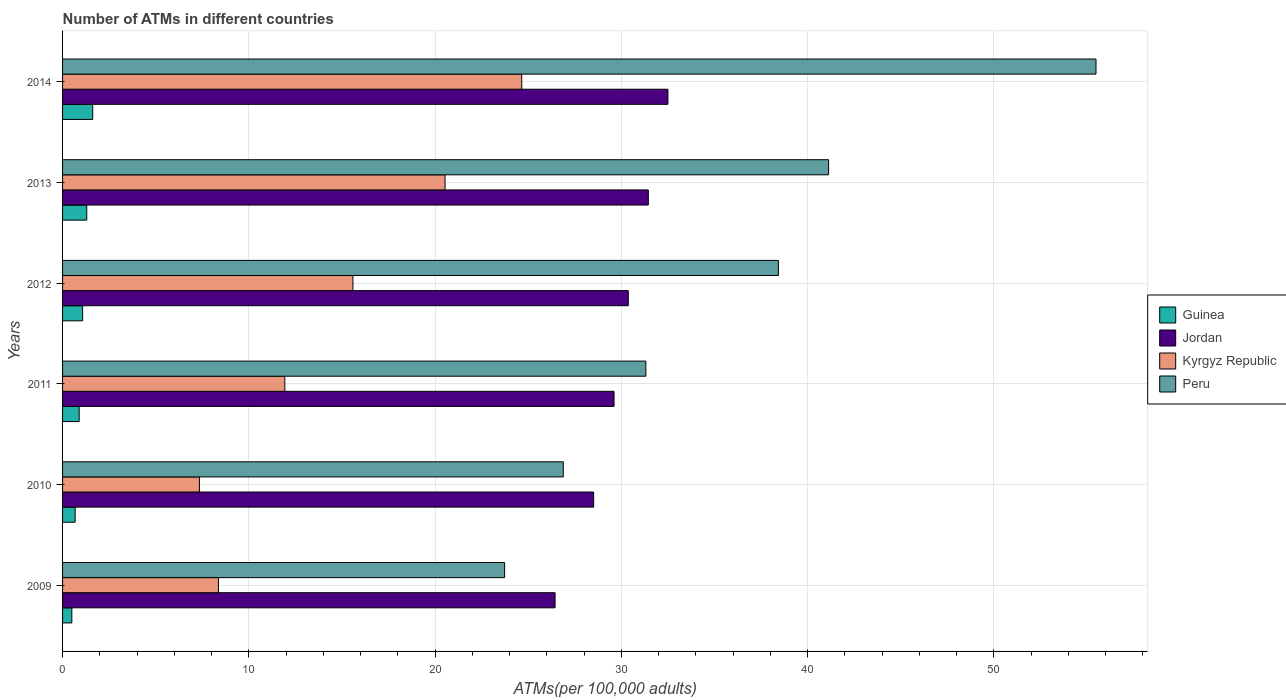How many different coloured bars are there?
Your answer should be very brief. 4. Are the number of bars per tick equal to the number of legend labels?
Ensure brevity in your answer.  Yes. How many bars are there on the 6th tick from the top?
Keep it short and to the point. 4. What is the label of the 2nd group of bars from the top?
Your answer should be compact. 2013. In how many cases, is the number of bars for a given year not equal to the number of legend labels?
Provide a short and direct response. 0. What is the number of ATMs in Kyrgyz Republic in 2009?
Give a very brief answer. 8.37. Across all years, what is the maximum number of ATMs in Kyrgyz Republic?
Ensure brevity in your answer.  24.65. Across all years, what is the minimum number of ATMs in Jordan?
Keep it short and to the point. 26.44. What is the total number of ATMs in Kyrgyz Republic in the graph?
Your answer should be very brief. 88.42. What is the difference between the number of ATMs in Jordan in 2013 and that in 2014?
Offer a terse response. -1.05. What is the difference between the number of ATMs in Guinea in 2009 and the number of ATMs in Kyrgyz Republic in 2012?
Offer a terse response. -15.09. What is the average number of ATMs in Guinea per year?
Offer a terse response. 1.01. In the year 2013, what is the difference between the number of ATMs in Kyrgyz Republic and number of ATMs in Jordan?
Offer a very short reply. -10.91. In how many years, is the number of ATMs in Guinea greater than 12 ?
Offer a very short reply. 0. What is the ratio of the number of ATMs in Kyrgyz Republic in 2010 to that in 2014?
Offer a very short reply. 0.3. What is the difference between the highest and the second highest number of ATMs in Jordan?
Provide a succinct answer. 1.05. What is the difference between the highest and the lowest number of ATMs in Kyrgyz Republic?
Make the answer very short. 17.3. In how many years, is the number of ATMs in Kyrgyz Republic greater than the average number of ATMs in Kyrgyz Republic taken over all years?
Keep it short and to the point. 3. Is the sum of the number of ATMs in Peru in 2010 and 2011 greater than the maximum number of ATMs in Kyrgyz Republic across all years?
Give a very brief answer. Yes. Is it the case that in every year, the sum of the number of ATMs in Kyrgyz Republic and number of ATMs in Peru is greater than the sum of number of ATMs in Guinea and number of ATMs in Jordan?
Your response must be concise. No. What does the 2nd bar from the top in 2014 represents?
Keep it short and to the point. Kyrgyz Republic. What does the 3rd bar from the bottom in 2009 represents?
Keep it short and to the point. Kyrgyz Republic. Is it the case that in every year, the sum of the number of ATMs in Guinea and number of ATMs in Kyrgyz Republic is greater than the number of ATMs in Jordan?
Your response must be concise. No. Are all the bars in the graph horizontal?
Keep it short and to the point. Yes. How are the legend labels stacked?
Provide a succinct answer. Vertical. What is the title of the graph?
Your answer should be very brief. Number of ATMs in different countries. Does "Pakistan" appear as one of the legend labels in the graph?
Offer a very short reply. No. What is the label or title of the X-axis?
Your response must be concise. ATMs(per 100,0 adults). What is the label or title of the Y-axis?
Keep it short and to the point. Years. What is the ATMs(per 100,000 adults) of Guinea in 2009?
Provide a short and direct response. 0.5. What is the ATMs(per 100,000 adults) in Jordan in 2009?
Keep it short and to the point. 26.44. What is the ATMs(per 100,000 adults) in Kyrgyz Republic in 2009?
Offer a terse response. 8.37. What is the ATMs(per 100,000 adults) in Peru in 2009?
Your response must be concise. 23.73. What is the ATMs(per 100,000 adults) in Guinea in 2010?
Keep it short and to the point. 0.68. What is the ATMs(per 100,000 adults) of Jordan in 2010?
Ensure brevity in your answer.  28.51. What is the ATMs(per 100,000 adults) of Kyrgyz Republic in 2010?
Your answer should be very brief. 7.35. What is the ATMs(per 100,000 adults) in Peru in 2010?
Provide a short and direct response. 26.88. What is the ATMs(per 100,000 adults) of Guinea in 2011?
Your answer should be very brief. 0.89. What is the ATMs(per 100,000 adults) in Jordan in 2011?
Provide a short and direct response. 29.61. What is the ATMs(per 100,000 adults) of Kyrgyz Republic in 2011?
Provide a short and direct response. 11.93. What is the ATMs(per 100,000 adults) in Peru in 2011?
Your answer should be very brief. 31.31. What is the ATMs(per 100,000 adults) in Guinea in 2012?
Provide a succinct answer. 1.08. What is the ATMs(per 100,000 adults) of Jordan in 2012?
Keep it short and to the point. 30.37. What is the ATMs(per 100,000 adults) in Kyrgyz Republic in 2012?
Make the answer very short. 15.59. What is the ATMs(per 100,000 adults) of Peru in 2012?
Provide a succinct answer. 38.43. What is the ATMs(per 100,000 adults) of Guinea in 2013?
Keep it short and to the point. 1.3. What is the ATMs(per 100,000 adults) in Jordan in 2013?
Give a very brief answer. 31.45. What is the ATMs(per 100,000 adults) in Kyrgyz Republic in 2013?
Offer a very short reply. 20.53. What is the ATMs(per 100,000 adults) in Peru in 2013?
Your answer should be very brief. 41.12. What is the ATMs(per 100,000 adults) of Guinea in 2014?
Offer a terse response. 1.62. What is the ATMs(per 100,000 adults) in Jordan in 2014?
Your response must be concise. 32.5. What is the ATMs(per 100,000 adults) of Kyrgyz Republic in 2014?
Your response must be concise. 24.65. What is the ATMs(per 100,000 adults) of Peru in 2014?
Your answer should be very brief. 55.48. Across all years, what is the maximum ATMs(per 100,000 adults) of Guinea?
Keep it short and to the point. 1.62. Across all years, what is the maximum ATMs(per 100,000 adults) of Jordan?
Offer a very short reply. 32.5. Across all years, what is the maximum ATMs(per 100,000 adults) of Kyrgyz Republic?
Your answer should be very brief. 24.65. Across all years, what is the maximum ATMs(per 100,000 adults) in Peru?
Provide a short and direct response. 55.48. Across all years, what is the minimum ATMs(per 100,000 adults) in Guinea?
Keep it short and to the point. 0.5. Across all years, what is the minimum ATMs(per 100,000 adults) of Jordan?
Your answer should be compact. 26.44. Across all years, what is the minimum ATMs(per 100,000 adults) of Kyrgyz Republic?
Provide a short and direct response. 7.35. Across all years, what is the minimum ATMs(per 100,000 adults) in Peru?
Make the answer very short. 23.73. What is the total ATMs(per 100,000 adults) of Guinea in the graph?
Provide a succinct answer. 6.06. What is the total ATMs(per 100,000 adults) in Jordan in the graph?
Your answer should be compact. 178.88. What is the total ATMs(per 100,000 adults) of Kyrgyz Republic in the graph?
Make the answer very short. 88.42. What is the total ATMs(per 100,000 adults) of Peru in the graph?
Give a very brief answer. 216.96. What is the difference between the ATMs(per 100,000 adults) of Guinea in 2009 and that in 2010?
Provide a succinct answer. -0.18. What is the difference between the ATMs(per 100,000 adults) of Jordan in 2009 and that in 2010?
Ensure brevity in your answer.  -2.07. What is the difference between the ATMs(per 100,000 adults) of Kyrgyz Republic in 2009 and that in 2010?
Your response must be concise. 1.02. What is the difference between the ATMs(per 100,000 adults) in Peru in 2009 and that in 2010?
Your answer should be very brief. -3.15. What is the difference between the ATMs(per 100,000 adults) of Guinea in 2009 and that in 2011?
Offer a terse response. -0.39. What is the difference between the ATMs(per 100,000 adults) of Jordan in 2009 and that in 2011?
Ensure brevity in your answer.  -3.17. What is the difference between the ATMs(per 100,000 adults) in Kyrgyz Republic in 2009 and that in 2011?
Offer a very short reply. -3.56. What is the difference between the ATMs(per 100,000 adults) of Peru in 2009 and that in 2011?
Give a very brief answer. -7.58. What is the difference between the ATMs(per 100,000 adults) in Guinea in 2009 and that in 2012?
Provide a succinct answer. -0.58. What is the difference between the ATMs(per 100,000 adults) in Jordan in 2009 and that in 2012?
Provide a short and direct response. -3.93. What is the difference between the ATMs(per 100,000 adults) in Kyrgyz Republic in 2009 and that in 2012?
Provide a short and direct response. -7.22. What is the difference between the ATMs(per 100,000 adults) of Peru in 2009 and that in 2012?
Ensure brevity in your answer.  -14.7. What is the difference between the ATMs(per 100,000 adults) in Guinea in 2009 and that in 2013?
Provide a succinct answer. -0.8. What is the difference between the ATMs(per 100,000 adults) in Jordan in 2009 and that in 2013?
Your response must be concise. -5.01. What is the difference between the ATMs(per 100,000 adults) of Kyrgyz Republic in 2009 and that in 2013?
Your answer should be compact. -12.16. What is the difference between the ATMs(per 100,000 adults) of Peru in 2009 and that in 2013?
Offer a terse response. -17.39. What is the difference between the ATMs(per 100,000 adults) of Guinea in 2009 and that in 2014?
Provide a succinct answer. -1.12. What is the difference between the ATMs(per 100,000 adults) of Jordan in 2009 and that in 2014?
Provide a short and direct response. -6.06. What is the difference between the ATMs(per 100,000 adults) of Kyrgyz Republic in 2009 and that in 2014?
Keep it short and to the point. -16.28. What is the difference between the ATMs(per 100,000 adults) in Peru in 2009 and that in 2014?
Keep it short and to the point. -31.75. What is the difference between the ATMs(per 100,000 adults) in Guinea in 2010 and that in 2011?
Offer a terse response. -0.21. What is the difference between the ATMs(per 100,000 adults) of Jordan in 2010 and that in 2011?
Provide a succinct answer. -1.09. What is the difference between the ATMs(per 100,000 adults) of Kyrgyz Republic in 2010 and that in 2011?
Provide a succinct answer. -4.58. What is the difference between the ATMs(per 100,000 adults) of Peru in 2010 and that in 2011?
Ensure brevity in your answer.  -4.43. What is the difference between the ATMs(per 100,000 adults) of Guinea in 2010 and that in 2012?
Keep it short and to the point. -0.4. What is the difference between the ATMs(per 100,000 adults) in Jordan in 2010 and that in 2012?
Offer a very short reply. -1.86. What is the difference between the ATMs(per 100,000 adults) in Kyrgyz Republic in 2010 and that in 2012?
Keep it short and to the point. -8.24. What is the difference between the ATMs(per 100,000 adults) of Peru in 2010 and that in 2012?
Ensure brevity in your answer.  -11.55. What is the difference between the ATMs(per 100,000 adults) of Guinea in 2010 and that in 2013?
Your answer should be compact. -0.62. What is the difference between the ATMs(per 100,000 adults) in Jordan in 2010 and that in 2013?
Your answer should be very brief. -2.94. What is the difference between the ATMs(per 100,000 adults) in Kyrgyz Republic in 2010 and that in 2013?
Your answer should be very brief. -13.19. What is the difference between the ATMs(per 100,000 adults) of Peru in 2010 and that in 2013?
Provide a short and direct response. -14.24. What is the difference between the ATMs(per 100,000 adults) of Guinea in 2010 and that in 2014?
Offer a very short reply. -0.94. What is the difference between the ATMs(per 100,000 adults) in Jordan in 2010 and that in 2014?
Your answer should be very brief. -3.99. What is the difference between the ATMs(per 100,000 adults) of Kyrgyz Republic in 2010 and that in 2014?
Offer a very short reply. -17.3. What is the difference between the ATMs(per 100,000 adults) of Peru in 2010 and that in 2014?
Your answer should be very brief. -28.6. What is the difference between the ATMs(per 100,000 adults) of Guinea in 2011 and that in 2012?
Provide a succinct answer. -0.19. What is the difference between the ATMs(per 100,000 adults) of Jordan in 2011 and that in 2012?
Provide a succinct answer. -0.76. What is the difference between the ATMs(per 100,000 adults) in Kyrgyz Republic in 2011 and that in 2012?
Provide a succinct answer. -3.66. What is the difference between the ATMs(per 100,000 adults) of Peru in 2011 and that in 2012?
Your answer should be compact. -7.12. What is the difference between the ATMs(per 100,000 adults) of Guinea in 2011 and that in 2013?
Provide a short and direct response. -0.41. What is the difference between the ATMs(per 100,000 adults) of Jordan in 2011 and that in 2013?
Offer a very short reply. -1.84. What is the difference between the ATMs(per 100,000 adults) of Kyrgyz Republic in 2011 and that in 2013?
Make the answer very short. -8.6. What is the difference between the ATMs(per 100,000 adults) of Peru in 2011 and that in 2013?
Provide a short and direct response. -9.81. What is the difference between the ATMs(per 100,000 adults) of Guinea in 2011 and that in 2014?
Keep it short and to the point. -0.73. What is the difference between the ATMs(per 100,000 adults) of Jordan in 2011 and that in 2014?
Keep it short and to the point. -2.89. What is the difference between the ATMs(per 100,000 adults) of Kyrgyz Republic in 2011 and that in 2014?
Keep it short and to the point. -12.72. What is the difference between the ATMs(per 100,000 adults) in Peru in 2011 and that in 2014?
Give a very brief answer. -24.17. What is the difference between the ATMs(per 100,000 adults) in Guinea in 2012 and that in 2013?
Make the answer very short. -0.22. What is the difference between the ATMs(per 100,000 adults) of Jordan in 2012 and that in 2013?
Offer a terse response. -1.08. What is the difference between the ATMs(per 100,000 adults) in Kyrgyz Republic in 2012 and that in 2013?
Your response must be concise. -4.95. What is the difference between the ATMs(per 100,000 adults) in Peru in 2012 and that in 2013?
Keep it short and to the point. -2.69. What is the difference between the ATMs(per 100,000 adults) of Guinea in 2012 and that in 2014?
Give a very brief answer. -0.54. What is the difference between the ATMs(per 100,000 adults) in Jordan in 2012 and that in 2014?
Provide a succinct answer. -2.13. What is the difference between the ATMs(per 100,000 adults) in Kyrgyz Republic in 2012 and that in 2014?
Your answer should be compact. -9.06. What is the difference between the ATMs(per 100,000 adults) in Peru in 2012 and that in 2014?
Your answer should be very brief. -17.05. What is the difference between the ATMs(per 100,000 adults) in Guinea in 2013 and that in 2014?
Make the answer very short. -0.32. What is the difference between the ATMs(per 100,000 adults) of Jordan in 2013 and that in 2014?
Provide a succinct answer. -1.05. What is the difference between the ATMs(per 100,000 adults) in Kyrgyz Republic in 2013 and that in 2014?
Ensure brevity in your answer.  -4.12. What is the difference between the ATMs(per 100,000 adults) of Peru in 2013 and that in 2014?
Give a very brief answer. -14.36. What is the difference between the ATMs(per 100,000 adults) in Guinea in 2009 and the ATMs(per 100,000 adults) in Jordan in 2010?
Provide a short and direct response. -28.01. What is the difference between the ATMs(per 100,000 adults) in Guinea in 2009 and the ATMs(per 100,000 adults) in Kyrgyz Republic in 2010?
Make the answer very short. -6.85. What is the difference between the ATMs(per 100,000 adults) in Guinea in 2009 and the ATMs(per 100,000 adults) in Peru in 2010?
Your answer should be compact. -26.39. What is the difference between the ATMs(per 100,000 adults) in Jordan in 2009 and the ATMs(per 100,000 adults) in Kyrgyz Republic in 2010?
Your response must be concise. 19.09. What is the difference between the ATMs(per 100,000 adults) of Jordan in 2009 and the ATMs(per 100,000 adults) of Peru in 2010?
Your answer should be compact. -0.44. What is the difference between the ATMs(per 100,000 adults) of Kyrgyz Republic in 2009 and the ATMs(per 100,000 adults) of Peru in 2010?
Your answer should be compact. -18.51. What is the difference between the ATMs(per 100,000 adults) of Guinea in 2009 and the ATMs(per 100,000 adults) of Jordan in 2011?
Offer a terse response. -29.11. What is the difference between the ATMs(per 100,000 adults) in Guinea in 2009 and the ATMs(per 100,000 adults) in Kyrgyz Republic in 2011?
Provide a short and direct response. -11.43. What is the difference between the ATMs(per 100,000 adults) in Guinea in 2009 and the ATMs(per 100,000 adults) in Peru in 2011?
Ensure brevity in your answer.  -30.82. What is the difference between the ATMs(per 100,000 adults) of Jordan in 2009 and the ATMs(per 100,000 adults) of Kyrgyz Republic in 2011?
Keep it short and to the point. 14.51. What is the difference between the ATMs(per 100,000 adults) in Jordan in 2009 and the ATMs(per 100,000 adults) in Peru in 2011?
Offer a very short reply. -4.87. What is the difference between the ATMs(per 100,000 adults) of Kyrgyz Republic in 2009 and the ATMs(per 100,000 adults) of Peru in 2011?
Ensure brevity in your answer.  -22.95. What is the difference between the ATMs(per 100,000 adults) of Guinea in 2009 and the ATMs(per 100,000 adults) of Jordan in 2012?
Give a very brief answer. -29.87. What is the difference between the ATMs(per 100,000 adults) in Guinea in 2009 and the ATMs(per 100,000 adults) in Kyrgyz Republic in 2012?
Make the answer very short. -15.09. What is the difference between the ATMs(per 100,000 adults) of Guinea in 2009 and the ATMs(per 100,000 adults) of Peru in 2012?
Offer a very short reply. -37.93. What is the difference between the ATMs(per 100,000 adults) in Jordan in 2009 and the ATMs(per 100,000 adults) in Kyrgyz Republic in 2012?
Your answer should be compact. 10.85. What is the difference between the ATMs(per 100,000 adults) of Jordan in 2009 and the ATMs(per 100,000 adults) of Peru in 2012?
Give a very brief answer. -11.99. What is the difference between the ATMs(per 100,000 adults) in Kyrgyz Republic in 2009 and the ATMs(per 100,000 adults) in Peru in 2012?
Offer a terse response. -30.06. What is the difference between the ATMs(per 100,000 adults) of Guinea in 2009 and the ATMs(per 100,000 adults) of Jordan in 2013?
Offer a very short reply. -30.95. What is the difference between the ATMs(per 100,000 adults) of Guinea in 2009 and the ATMs(per 100,000 adults) of Kyrgyz Republic in 2013?
Provide a short and direct response. -20.04. What is the difference between the ATMs(per 100,000 adults) in Guinea in 2009 and the ATMs(per 100,000 adults) in Peru in 2013?
Keep it short and to the point. -40.63. What is the difference between the ATMs(per 100,000 adults) of Jordan in 2009 and the ATMs(per 100,000 adults) of Kyrgyz Republic in 2013?
Your answer should be compact. 5.91. What is the difference between the ATMs(per 100,000 adults) in Jordan in 2009 and the ATMs(per 100,000 adults) in Peru in 2013?
Provide a short and direct response. -14.68. What is the difference between the ATMs(per 100,000 adults) of Kyrgyz Republic in 2009 and the ATMs(per 100,000 adults) of Peru in 2013?
Give a very brief answer. -32.76. What is the difference between the ATMs(per 100,000 adults) of Guinea in 2009 and the ATMs(per 100,000 adults) of Jordan in 2014?
Offer a very short reply. -32. What is the difference between the ATMs(per 100,000 adults) in Guinea in 2009 and the ATMs(per 100,000 adults) in Kyrgyz Republic in 2014?
Provide a succinct answer. -24.15. What is the difference between the ATMs(per 100,000 adults) in Guinea in 2009 and the ATMs(per 100,000 adults) in Peru in 2014?
Give a very brief answer. -54.98. What is the difference between the ATMs(per 100,000 adults) of Jordan in 2009 and the ATMs(per 100,000 adults) of Kyrgyz Republic in 2014?
Offer a very short reply. 1.79. What is the difference between the ATMs(per 100,000 adults) in Jordan in 2009 and the ATMs(per 100,000 adults) in Peru in 2014?
Make the answer very short. -29.04. What is the difference between the ATMs(per 100,000 adults) of Kyrgyz Republic in 2009 and the ATMs(per 100,000 adults) of Peru in 2014?
Make the answer very short. -47.11. What is the difference between the ATMs(per 100,000 adults) of Guinea in 2010 and the ATMs(per 100,000 adults) of Jordan in 2011?
Your answer should be compact. -28.93. What is the difference between the ATMs(per 100,000 adults) in Guinea in 2010 and the ATMs(per 100,000 adults) in Kyrgyz Republic in 2011?
Provide a succinct answer. -11.26. What is the difference between the ATMs(per 100,000 adults) in Guinea in 2010 and the ATMs(per 100,000 adults) in Peru in 2011?
Provide a short and direct response. -30.64. What is the difference between the ATMs(per 100,000 adults) of Jordan in 2010 and the ATMs(per 100,000 adults) of Kyrgyz Republic in 2011?
Give a very brief answer. 16.58. What is the difference between the ATMs(per 100,000 adults) in Jordan in 2010 and the ATMs(per 100,000 adults) in Peru in 2011?
Provide a succinct answer. -2.8. What is the difference between the ATMs(per 100,000 adults) of Kyrgyz Republic in 2010 and the ATMs(per 100,000 adults) of Peru in 2011?
Provide a short and direct response. -23.97. What is the difference between the ATMs(per 100,000 adults) in Guinea in 2010 and the ATMs(per 100,000 adults) in Jordan in 2012?
Provide a succinct answer. -29.7. What is the difference between the ATMs(per 100,000 adults) of Guinea in 2010 and the ATMs(per 100,000 adults) of Kyrgyz Republic in 2012?
Make the answer very short. -14.91. What is the difference between the ATMs(per 100,000 adults) in Guinea in 2010 and the ATMs(per 100,000 adults) in Peru in 2012?
Make the answer very short. -37.76. What is the difference between the ATMs(per 100,000 adults) in Jordan in 2010 and the ATMs(per 100,000 adults) in Kyrgyz Republic in 2012?
Your answer should be compact. 12.92. What is the difference between the ATMs(per 100,000 adults) in Jordan in 2010 and the ATMs(per 100,000 adults) in Peru in 2012?
Make the answer very short. -9.92. What is the difference between the ATMs(per 100,000 adults) in Kyrgyz Republic in 2010 and the ATMs(per 100,000 adults) in Peru in 2012?
Make the answer very short. -31.08. What is the difference between the ATMs(per 100,000 adults) of Guinea in 2010 and the ATMs(per 100,000 adults) of Jordan in 2013?
Provide a short and direct response. -30.77. What is the difference between the ATMs(per 100,000 adults) in Guinea in 2010 and the ATMs(per 100,000 adults) in Kyrgyz Republic in 2013?
Your answer should be compact. -19.86. What is the difference between the ATMs(per 100,000 adults) in Guinea in 2010 and the ATMs(per 100,000 adults) in Peru in 2013?
Make the answer very short. -40.45. What is the difference between the ATMs(per 100,000 adults) of Jordan in 2010 and the ATMs(per 100,000 adults) of Kyrgyz Republic in 2013?
Provide a short and direct response. 7.98. What is the difference between the ATMs(per 100,000 adults) of Jordan in 2010 and the ATMs(per 100,000 adults) of Peru in 2013?
Give a very brief answer. -12.61. What is the difference between the ATMs(per 100,000 adults) of Kyrgyz Republic in 2010 and the ATMs(per 100,000 adults) of Peru in 2013?
Offer a very short reply. -33.78. What is the difference between the ATMs(per 100,000 adults) of Guinea in 2010 and the ATMs(per 100,000 adults) of Jordan in 2014?
Provide a short and direct response. -31.82. What is the difference between the ATMs(per 100,000 adults) of Guinea in 2010 and the ATMs(per 100,000 adults) of Kyrgyz Republic in 2014?
Keep it short and to the point. -23.98. What is the difference between the ATMs(per 100,000 adults) of Guinea in 2010 and the ATMs(per 100,000 adults) of Peru in 2014?
Provide a succinct answer. -54.81. What is the difference between the ATMs(per 100,000 adults) of Jordan in 2010 and the ATMs(per 100,000 adults) of Kyrgyz Republic in 2014?
Offer a terse response. 3.86. What is the difference between the ATMs(per 100,000 adults) in Jordan in 2010 and the ATMs(per 100,000 adults) in Peru in 2014?
Your answer should be compact. -26.97. What is the difference between the ATMs(per 100,000 adults) in Kyrgyz Republic in 2010 and the ATMs(per 100,000 adults) in Peru in 2014?
Your answer should be compact. -48.13. What is the difference between the ATMs(per 100,000 adults) of Guinea in 2011 and the ATMs(per 100,000 adults) of Jordan in 2012?
Keep it short and to the point. -29.48. What is the difference between the ATMs(per 100,000 adults) in Guinea in 2011 and the ATMs(per 100,000 adults) in Kyrgyz Republic in 2012?
Make the answer very short. -14.7. What is the difference between the ATMs(per 100,000 adults) of Guinea in 2011 and the ATMs(per 100,000 adults) of Peru in 2012?
Provide a succinct answer. -37.54. What is the difference between the ATMs(per 100,000 adults) of Jordan in 2011 and the ATMs(per 100,000 adults) of Kyrgyz Republic in 2012?
Give a very brief answer. 14.02. What is the difference between the ATMs(per 100,000 adults) in Jordan in 2011 and the ATMs(per 100,000 adults) in Peru in 2012?
Provide a short and direct response. -8.82. What is the difference between the ATMs(per 100,000 adults) in Kyrgyz Republic in 2011 and the ATMs(per 100,000 adults) in Peru in 2012?
Keep it short and to the point. -26.5. What is the difference between the ATMs(per 100,000 adults) of Guinea in 2011 and the ATMs(per 100,000 adults) of Jordan in 2013?
Ensure brevity in your answer.  -30.56. What is the difference between the ATMs(per 100,000 adults) of Guinea in 2011 and the ATMs(per 100,000 adults) of Kyrgyz Republic in 2013?
Your answer should be very brief. -19.64. What is the difference between the ATMs(per 100,000 adults) of Guinea in 2011 and the ATMs(per 100,000 adults) of Peru in 2013?
Your answer should be very brief. -40.23. What is the difference between the ATMs(per 100,000 adults) in Jordan in 2011 and the ATMs(per 100,000 adults) in Kyrgyz Republic in 2013?
Offer a very short reply. 9.07. What is the difference between the ATMs(per 100,000 adults) of Jordan in 2011 and the ATMs(per 100,000 adults) of Peru in 2013?
Offer a terse response. -11.52. What is the difference between the ATMs(per 100,000 adults) of Kyrgyz Republic in 2011 and the ATMs(per 100,000 adults) of Peru in 2013?
Your response must be concise. -29.19. What is the difference between the ATMs(per 100,000 adults) of Guinea in 2011 and the ATMs(per 100,000 adults) of Jordan in 2014?
Make the answer very short. -31.61. What is the difference between the ATMs(per 100,000 adults) of Guinea in 2011 and the ATMs(per 100,000 adults) of Kyrgyz Republic in 2014?
Your answer should be compact. -23.76. What is the difference between the ATMs(per 100,000 adults) of Guinea in 2011 and the ATMs(per 100,000 adults) of Peru in 2014?
Give a very brief answer. -54.59. What is the difference between the ATMs(per 100,000 adults) in Jordan in 2011 and the ATMs(per 100,000 adults) in Kyrgyz Republic in 2014?
Offer a very short reply. 4.96. What is the difference between the ATMs(per 100,000 adults) of Jordan in 2011 and the ATMs(per 100,000 adults) of Peru in 2014?
Your response must be concise. -25.87. What is the difference between the ATMs(per 100,000 adults) in Kyrgyz Republic in 2011 and the ATMs(per 100,000 adults) in Peru in 2014?
Provide a short and direct response. -43.55. What is the difference between the ATMs(per 100,000 adults) of Guinea in 2012 and the ATMs(per 100,000 adults) of Jordan in 2013?
Make the answer very short. -30.37. What is the difference between the ATMs(per 100,000 adults) of Guinea in 2012 and the ATMs(per 100,000 adults) of Kyrgyz Republic in 2013?
Keep it short and to the point. -19.46. What is the difference between the ATMs(per 100,000 adults) of Guinea in 2012 and the ATMs(per 100,000 adults) of Peru in 2013?
Your answer should be compact. -40.05. What is the difference between the ATMs(per 100,000 adults) in Jordan in 2012 and the ATMs(per 100,000 adults) in Kyrgyz Republic in 2013?
Keep it short and to the point. 9.84. What is the difference between the ATMs(per 100,000 adults) of Jordan in 2012 and the ATMs(per 100,000 adults) of Peru in 2013?
Keep it short and to the point. -10.75. What is the difference between the ATMs(per 100,000 adults) in Kyrgyz Republic in 2012 and the ATMs(per 100,000 adults) in Peru in 2013?
Keep it short and to the point. -25.54. What is the difference between the ATMs(per 100,000 adults) of Guinea in 2012 and the ATMs(per 100,000 adults) of Jordan in 2014?
Give a very brief answer. -31.42. What is the difference between the ATMs(per 100,000 adults) of Guinea in 2012 and the ATMs(per 100,000 adults) of Kyrgyz Republic in 2014?
Provide a succinct answer. -23.57. What is the difference between the ATMs(per 100,000 adults) in Guinea in 2012 and the ATMs(per 100,000 adults) in Peru in 2014?
Provide a succinct answer. -54.4. What is the difference between the ATMs(per 100,000 adults) of Jordan in 2012 and the ATMs(per 100,000 adults) of Kyrgyz Republic in 2014?
Provide a succinct answer. 5.72. What is the difference between the ATMs(per 100,000 adults) in Jordan in 2012 and the ATMs(per 100,000 adults) in Peru in 2014?
Your answer should be compact. -25.11. What is the difference between the ATMs(per 100,000 adults) in Kyrgyz Republic in 2012 and the ATMs(per 100,000 adults) in Peru in 2014?
Provide a succinct answer. -39.89. What is the difference between the ATMs(per 100,000 adults) of Guinea in 2013 and the ATMs(per 100,000 adults) of Jordan in 2014?
Your answer should be very brief. -31.2. What is the difference between the ATMs(per 100,000 adults) of Guinea in 2013 and the ATMs(per 100,000 adults) of Kyrgyz Republic in 2014?
Offer a terse response. -23.35. What is the difference between the ATMs(per 100,000 adults) of Guinea in 2013 and the ATMs(per 100,000 adults) of Peru in 2014?
Offer a terse response. -54.18. What is the difference between the ATMs(per 100,000 adults) of Jordan in 2013 and the ATMs(per 100,000 adults) of Kyrgyz Republic in 2014?
Your answer should be very brief. 6.8. What is the difference between the ATMs(per 100,000 adults) of Jordan in 2013 and the ATMs(per 100,000 adults) of Peru in 2014?
Give a very brief answer. -24.03. What is the difference between the ATMs(per 100,000 adults) in Kyrgyz Republic in 2013 and the ATMs(per 100,000 adults) in Peru in 2014?
Give a very brief answer. -34.95. What is the average ATMs(per 100,000 adults) of Guinea per year?
Keep it short and to the point. 1.01. What is the average ATMs(per 100,000 adults) in Jordan per year?
Offer a terse response. 29.81. What is the average ATMs(per 100,000 adults) in Kyrgyz Republic per year?
Offer a terse response. 14.74. What is the average ATMs(per 100,000 adults) of Peru per year?
Your response must be concise. 36.16. In the year 2009, what is the difference between the ATMs(per 100,000 adults) in Guinea and ATMs(per 100,000 adults) in Jordan?
Provide a succinct answer. -25.94. In the year 2009, what is the difference between the ATMs(per 100,000 adults) of Guinea and ATMs(per 100,000 adults) of Kyrgyz Republic?
Provide a succinct answer. -7.87. In the year 2009, what is the difference between the ATMs(per 100,000 adults) in Guinea and ATMs(per 100,000 adults) in Peru?
Make the answer very short. -23.23. In the year 2009, what is the difference between the ATMs(per 100,000 adults) of Jordan and ATMs(per 100,000 adults) of Kyrgyz Republic?
Offer a terse response. 18.07. In the year 2009, what is the difference between the ATMs(per 100,000 adults) of Jordan and ATMs(per 100,000 adults) of Peru?
Provide a succinct answer. 2.71. In the year 2009, what is the difference between the ATMs(per 100,000 adults) in Kyrgyz Republic and ATMs(per 100,000 adults) in Peru?
Your answer should be very brief. -15.36. In the year 2010, what is the difference between the ATMs(per 100,000 adults) in Guinea and ATMs(per 100,000 adults) in Jordan?
Provide a short and direct response. -27.84. In the year 2010, what is the difference between the ATMs(per 100,000 adults) in Guinea and ATMs(per 100,000 adults) in Kyrgyz Republic?
Give a very brief answer. -6.67. In the year 2010, what is the difference between the ATMs(per 100,000 adults) of Guinea and ATMs(per 100,000 adults) of Peru?
Provide a succinct answer. -26.21. In the year 2010, what is the difference between the ATMs(per 100,000 adults) of Jordan and ATMs(per 100,000 adults) of Kyrgyz Republic?
Provide a succinct answer. 21.16. In the year 2010, what is the difference between the ATMs(per 100,000 adults) of Jordan and ATMs(per 100,000 adults) of Peru?
Offer a terse response. 1.63. In the year 2010, what is the difference between the ATMs(per 100,000 adults) in Kyrgyz Republic and ATMs(per 100,000 adults) in Peru?
Your answer should be compact. -19.54. In the year 2011, what is the difference between the ATMs(per 100,000 adults) of Guinea and ATMs(per 100,000 adults) of Jordan?
Give a very brief answer. -28.72. In the year 2011, what is the difference between the ATMs(per 100,000 adults) of Guinea and ATMs(per 100,000 adults) of Kyrgyz Republic?
Your answer should be compact. -11.04. In the year 2011, what is the difference between the ATMs(per 100,000 adults) in Guinea and ATMs(per 100,000 adults) in Peru?
Make the answer very short. -30.42. In the year 2011, what is the difference between the ATMs(per 100,000 adults) in Jordan and ATMs(per 100,000 adults) in Kyrgyz Republic?
Make the answer very short. 17.67. In the year 2011, what is the difference between the ATMs(per 100,000 adults) of Jordan and ATMs(per 100,000 adults) of Peru?
Your response must be concise. -1.71. In the year 2011, what is the difference between the ATMs(per 100,000 adults) of Kyrgyz Republic and ATMs(per 100,000 adults) of Peru?
Your response must be concise. -19.38. In the year 2012, what is the difference between the ATMs(per 100,000 adults) of Guinea and ATMs(per 100,000 adults) of Jordan?
Make the answer very short. -29.29. In the year 2012, what is the difference between the ATMs(per 100,000 adults) of Guinea and ATMs(per 100,000 adults) of Kyrgyz Republic?
Make the answer very short. -14.51. In the year 2012, what is the difference between the ATMs(per 100,000 adults) in Guinea and ATMs(per 100,000 adults) in Peru?
Ensure brevity in your answer.  -37.35. In the year 2012, what is the difference between the ATMs(per 100,000 adults) of Jordan and ATMs(per 100,000 adults) of Kyrgyz Republic?
Give a very brief answer. 14.78. In the year 2012, what is the difference between the ATMs(per 100,000 adults) of Jordan and ATMs(per 100,000 adults) of Peru?
Keep it short and to the point. -8.06. In the year 2012, what is the difference between the ATMs(per 100,000 adults) in Kyrgyz Republic and ATMs(per 100,000 adults) in Peru?
Offer a terse response. -22.84. In the year 2013, what is the difference between the ATMs(per 100,000 adults) in Guinea and ATMs(per 100,000 adults) in Jordan?
Your answer should be compact. -30.15. In the year 2013, what is the difference between the ATMs(per 100,000 adults) of Guinea and ATMs(per 100,000 adults) of Kyrgyz Republic?
Keep it short and to the point. -19.23. In the year 2013, what is the difference between the ATMs(per 100,000 adults) of Guinea and ATMs(per 100,000 adults) of Peru?
Provide a succinct answer. -39.83. In the year 2013, what is the difference between the ATMs(per 100,000 adults) in Jordan and ATMs(per 100,000 adults) in Kyrgyz Republic?
Provide a succinct answer. 10.91. In the year 2013, what is the difference between the ATMs(per 100,000 adults) in Jordan and ATMs(per 100,000 adults) in Peru?
Offer a very short reply. -9.68. In the year 2013, what is the difference between the ATMs(per 100,000 adults) in Kyrgyz Republic and ATMs(per 100,000 adults) in Peru?
Provide a succinct answer. -20.59. In the year 2014, what is the difference between the ATMs(per 100,000 adults) of Guinea and ATMs(per 100,000 adults) of Jordan?
Keep it short and to the point. -30.88. In the year 2014, what is the difference between the ATMs(per 100,000 adults) of Guinea and ATMs(per 100,000 adults) of Kyrgyz Republic?
Your response must be concise. -23.03. In the year 2014, what is the difference between the ATMs(per 100,000 adults) in Guinea and ATMs(per 100,000 adults) in Peru?
Offer a very short reply. -53.86. In the year 2014, what is the difference between the ATMs(per 100,000 adults) in Jordan and ATMs(per 100,000 adults) in Kyrgyz Republic?
Provide a succinct answer. 7.85. In the year 2014, what is the difference between the ATMs(per 100,000 adults) of Jordan and ATMs(per 100,000 adults) of Peru?
Give a very brief answer. -22.98. In the year 2014, what is the difference between the ATMs(per 100,000 adults) of Kyrgyz Republic and ATMs(per 100,000 adults) of Peru?
Provide a succinct answer. -30.83. What is the ratio of the ATMs(per 100,000 adults) of Guinea in 2009 to that in 2010?
Ensure brevity in your answer.  0.74. What is the ratio of the ATMs(per 100,000 adults) in Jordan in 2009 to that in 2010?
Offer a very short reply. 0.93. What is the ratio of the ATMs(per 100,000 adults) in Kyrgyz Republic in 2009 to that in 2010?
Offer a very short reply. 1.14. What is the ratio of the ATMs(per 100,000 adults) in Peru in 2009 to that in 2010?
Offer a very short reply. 0.88. What is the ratio of the ATMs(per 100,000 adults) in Guinea in 2009 to that in 2011?
Give a very brief answer. 0.56. What is the ratio of the ATMs(per 100,000 adults) in Jordan in 2009 to that in 2011?
Offer a terse response. 0.89. What is the ratio of the ATMs(per 100,000 adults) in Kyrgyz Republic in 2009 to that in 2011?
Provide a succinct answer. 0.7. What is the ratio of the ATMs(per 100,000 adults) of Peru in 2009 to that in 2011?
Provide a short and direct response. 0.76. What is the ratio of the ATMs(per 100,000 adults) of Guinea in 2009 to that in 2012?
Keep it short and to the point. 0.46. What is the ratio of the ATMs(per 100,000 adults) in Jordan in 2009 to that in 2012?
Offer a terse response. 0.87. What is the ratio of the ATMs(per 100,000 adults) of Kyrgyz Republic in 2009 to that in 2012?
Your answer should be very brief. 0.54. What is the ratio of the ATMs(per 100,000 adults) in Peru in 2009 to that in 2012?
Provide a short and direct response. 0.62. What is the ratio of the ATMs(per 100,000 adults) of Guinea in 2009 to that in 2013?
Offer a very short reply. 0.38. What is the ratio of the ATMs(per 100,000 adults) of Jordan in 2009 to that in 2013?
Ensure brevity in your answer.  0.84. What is the ratio of the ATMs(per 100,000 adults) of Kyrgyz Republic in 2009 to that in 2013?
Offer a terse response. 0.41. What is the ratio of the ATMs(per 100,000 adults) of Peru in 2009 to that in 2013?
Provide a succinct answer. 0.58. What is the ratio of the ATMs(per 100,000 adults) of Guinea in 2009 to that in 2014?
Keep it short and to the point. 0.31. What is the ratio of the ATMs(per 100,000 adults) in Jordan in 2009 to that in 2014?
Offer a terse response. 0.81. What is the ratio of the ATMs(per 100,000 adults) of Kyrgyz Republic in 2009 to that in 2014?
Offer a terse response. 0.34. What is the ratio of the ATMs(per 100,000 adults) of Peru in 2009 to that in 2014?
Ensure brevity in your answer.  0.43. What is the ratio of the ATMs(per 100,000 adults) in Guinea in 2010 to that in 2011?
Your response must be concise. 0.76. What is the ratio of the ATMs(per 100,000 adults) in Kyrgyz Republic in 2010 to that in 2011?
Your response must be concise. 0.62. What is the ratio of the ATMs(per 100,000 adults) in Peru in 2010 to that in 2011?
Ensure brevity in your answer.  0.86. What is the ratio of the ATMs(per 100,000 adults) of Guinea in 2010 to that in 2012?
Make the answer very short. 0.63. What is the ratio of the ATMs(per 100,000 adults) of Jordan in 2010 to that in 2012?
Your answer should be very brief. 0.94. What is the ratio of the ATMs(per 100,000 adults) of Kyrgyz Republic in 2010 to that in 2012?
Offer a very short reply. 0.47. What is the ratio of the ATMs(per 100,000 adults) in Peru in 2010 to that in 2012?
Keep it short and to the point. 0.7. What is the ratio of the ATMs(per 100,000 adults) in Guinea in 2010 to that in 2013?
Offer a very short reply. 0.52. What is the ratio of the ATMs(per 100,000 adults) in Jordan in 2010 to that in 2013?
Provide a short and direct response. 0.91. What is the ratio of the ATMs(per 100,000 adults) in Kyrgyz Republic in 2010 to that in 2013?
Offer a terse response. 0.36. What is the ratio of the ATMs(per 100,000 adults) of Peru in 2010 to that in 2013?
Give a very brief answer. 0.65. What is the ratio of the ATMs(per 100,000 adults) of Guinea in 2010 to that in 2014?
Provide a short and direct response. 0.42. What is the ratio of the ATMs(per 100,000 adults) of Jordan in 2010 to that in 2014?
Give a very brief answer. 0.88. What is the ratio of the ATMs(per 100,000 adults) of Kyrgyz Republic in 2010 to that in 2014?
Make the answer very short. 0.3. What is the ratio of the ATMs(per 100,000 adults) in Peru in 2010 to that in 2014?
Offer a terse response. 0.48. What is the ratio of the ATMs(per 100,000 adults) of Guinea in 2011 to that in 2012?
Give a very brief answer. 0.83. What is the ratio of the ATMs(per 100,000 adults) of Jordan in 2011 to that in 2012?
Offer a terse response. 0.97. What is the ratio of the ATMs(per 100,000 adults) in Kyrgyz Republic in 2011 to that in 2012?
Your answer should be very brief. 0.77. What is the ratio of the ATMs(per 100,000 adults) of Peru in 2011 to that in 2012?
Provide a succinct answer. 0.81. What is the ratio of the ATMs(per 100,000 adults) in Guinea in 2011 to that in 2013?
Give a very brief answer. 0.69. What is the ratio of the ATMs(per 100,000 adults) of Jordan in 2011 to that in 2013?
Offer a terse response. 0.94. What is the ratio of the ATMs(per 100,000 adults) in Kyrgyz Republic in 2011 to that in 2013?
Ensure brevity in your answer.  0.58. What is the ratio of the ATMs(per 100,000 adults) in Peru in 2011 to that in 2013?
Your response must be concise. 0.76. What is the ratio of the ATMs(per 100,000 adults) in Guinea in 2011 to that in 2014?
Ensure brevity in your answer.  0.55. What is the ratio of the ATMs(per 100,000 adults) of Jordan in 2011 to that in 2014?
Ensure brevity in your answer.  0.91. What is the ratio of the ATMs(per 100,000 adults) of Kyrgyz Republic in 2011 to that in 2014?
Your answer should be compact. 0.48. What is the ratio of the ATMs(per 100,000 adults) in Peru in 2011 to that in 2014?
Your response must be concise. 0.56. What is the ratio of the ATMs(per 100,000 adults) in Guinea in 2012 to that in 2013?
Keep it short and to the point. 0.83. What is the ratio of the ATMs(per 100,000 adults) of Jordan in 2012 to that in 2013?
Give a very brief answer. 0.97. What is the ratio of the ATMs(per 100,000 adults) in Kyrgyz Republic in 2012 to that in 2013?
Your response must be concise. 0.76. What is the ratio of the ATMs(per 100,000 adults) of Peru in 2012 to that in 2013?
Give a very brief answer. 0.93. What is the ratio of the ATMs(per 100,000 adults) of Guinea in 2012 to that in 2014?
Your answer should be compact. 0.67. What is the ratio of the ATMs(per 100,000 adults) of Jordan in 2012 to that in 2014?
Keep it short and to the point. 0.93. What is the ratio of the ATMs(per 100,000 adults) of Kyrgyz Republic in 2012 to that in 2014?
Your answer should be very brief. 0.63. What is the ratio of the ATMs(per 100,000 adults) in Peru in 2012 to that in 2014?
Provide a short and direct response. 0.69. What is the ratio of the ATMs(per 100,000 adults) of Guinea in 2013 to that in 2014?
Ensure brevity in your answer.  0.8. What is the ratio of the ATMs(per 100,000 adults) of Jordan in 2013 to that in 2014?
Ensure brevity in your answer.  0.97. What is the ratio of the ATMs(per 100,000 adults) of Kyrgyz Republic in 2013 to that in 2014?
Keep it short and to the point. 0.83. What is the ratio of the ATMs(per 100,000 adults) of Peru in 2013 to that in 2014?
Your answer should be compact. 0.74. What is the difference between the highest and the second highest ATMs(per 100,000 adults) in Guinea?
Offer a terse response. 0.32. What is the difference between the highest and the second highest ATMs(per 100,000 adults) of Jordan?
Your answer should be compact. 1.05. What is the difference between the highest and the second highest ATMs(per 100,000 adults) of Kyrgyz Republic?
Your answer should be compact. 4.12. What is the difference between the highest and the second highest ATMs(per 100,000 adults) of Peru?
Keep it short and to the point. 14.36. What is the difference between the highest and the lowest ATMs(per 100,000 adults) in Guinea?
Give a very brief answer. 1.12. What is the difference between the highest and the lowest ATMs(per 100,000 adults) of Jordan?
Make the answer very short. 6.06. What is the difference between the highest and the lowest ATMs(per 100,000 adults) in Kyrgyz Republic?
Give a very brief answer. 17.3. What is the difference between the highest and the lowest ATMs(per 100,000 adults) in Peru?
Your answer should be very brief. 31.75. 